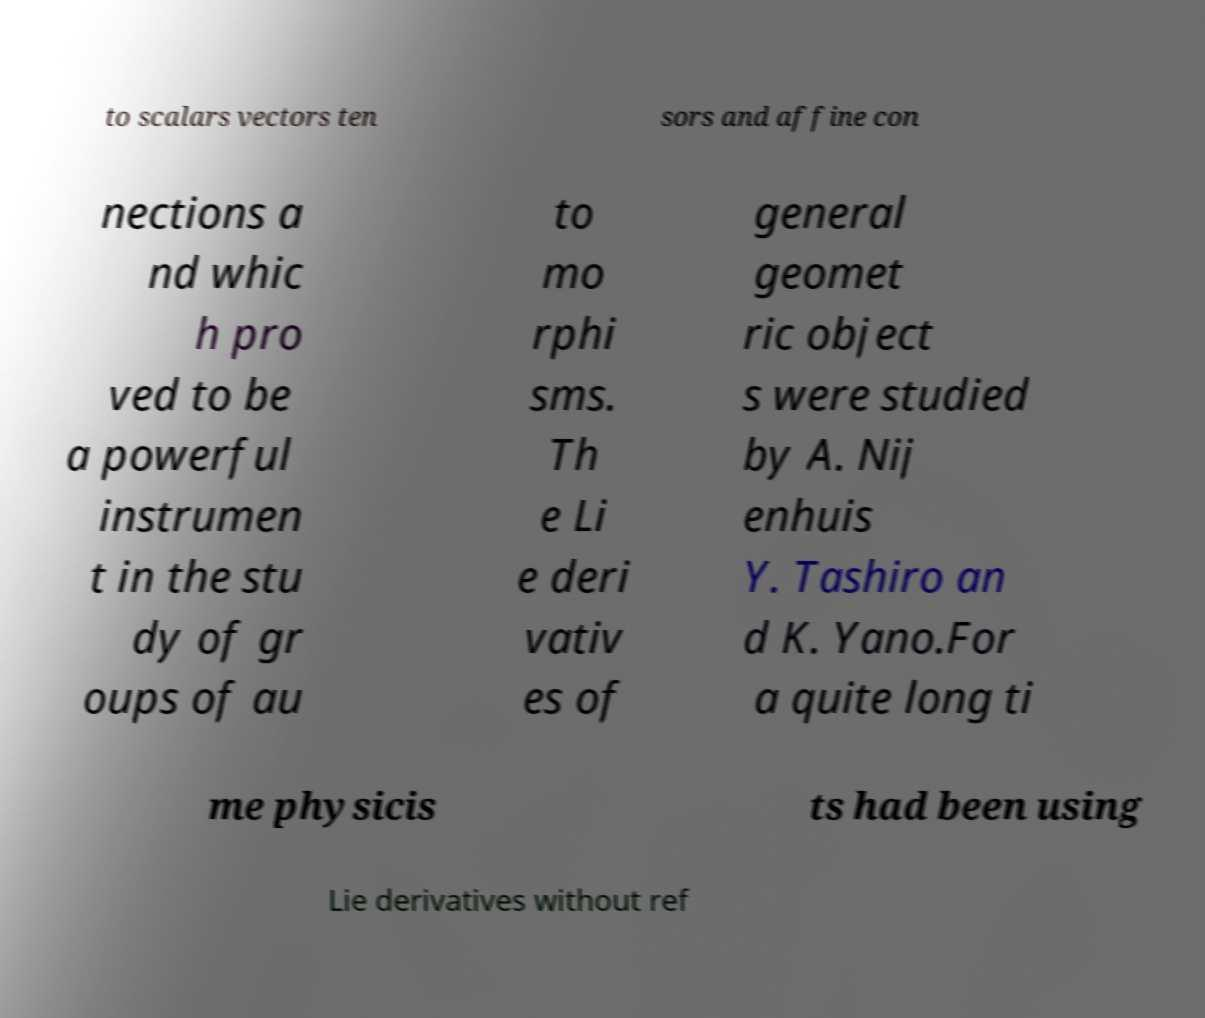Please read and relay the text visible in this image. What does it say? to scalars vectors ten sors and affine con nections a nd whic h pro ved to be a powerful instrumen t in the stu dy of gr oups of au to mo rphi sms. Th e Li e deri vativ es of general geomet ric object s were studied by A. Nij enhuis Y. Tashiro an d K. Yano.For a quite long ti me physicis ts had been using Lie derivatives without ref 